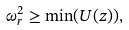<formula> <loc_0><loc_0><loc_500><loc_500>\omega _ { r } ^ { 2 } \geq \min ( U ( z ) ) ,</formula> 